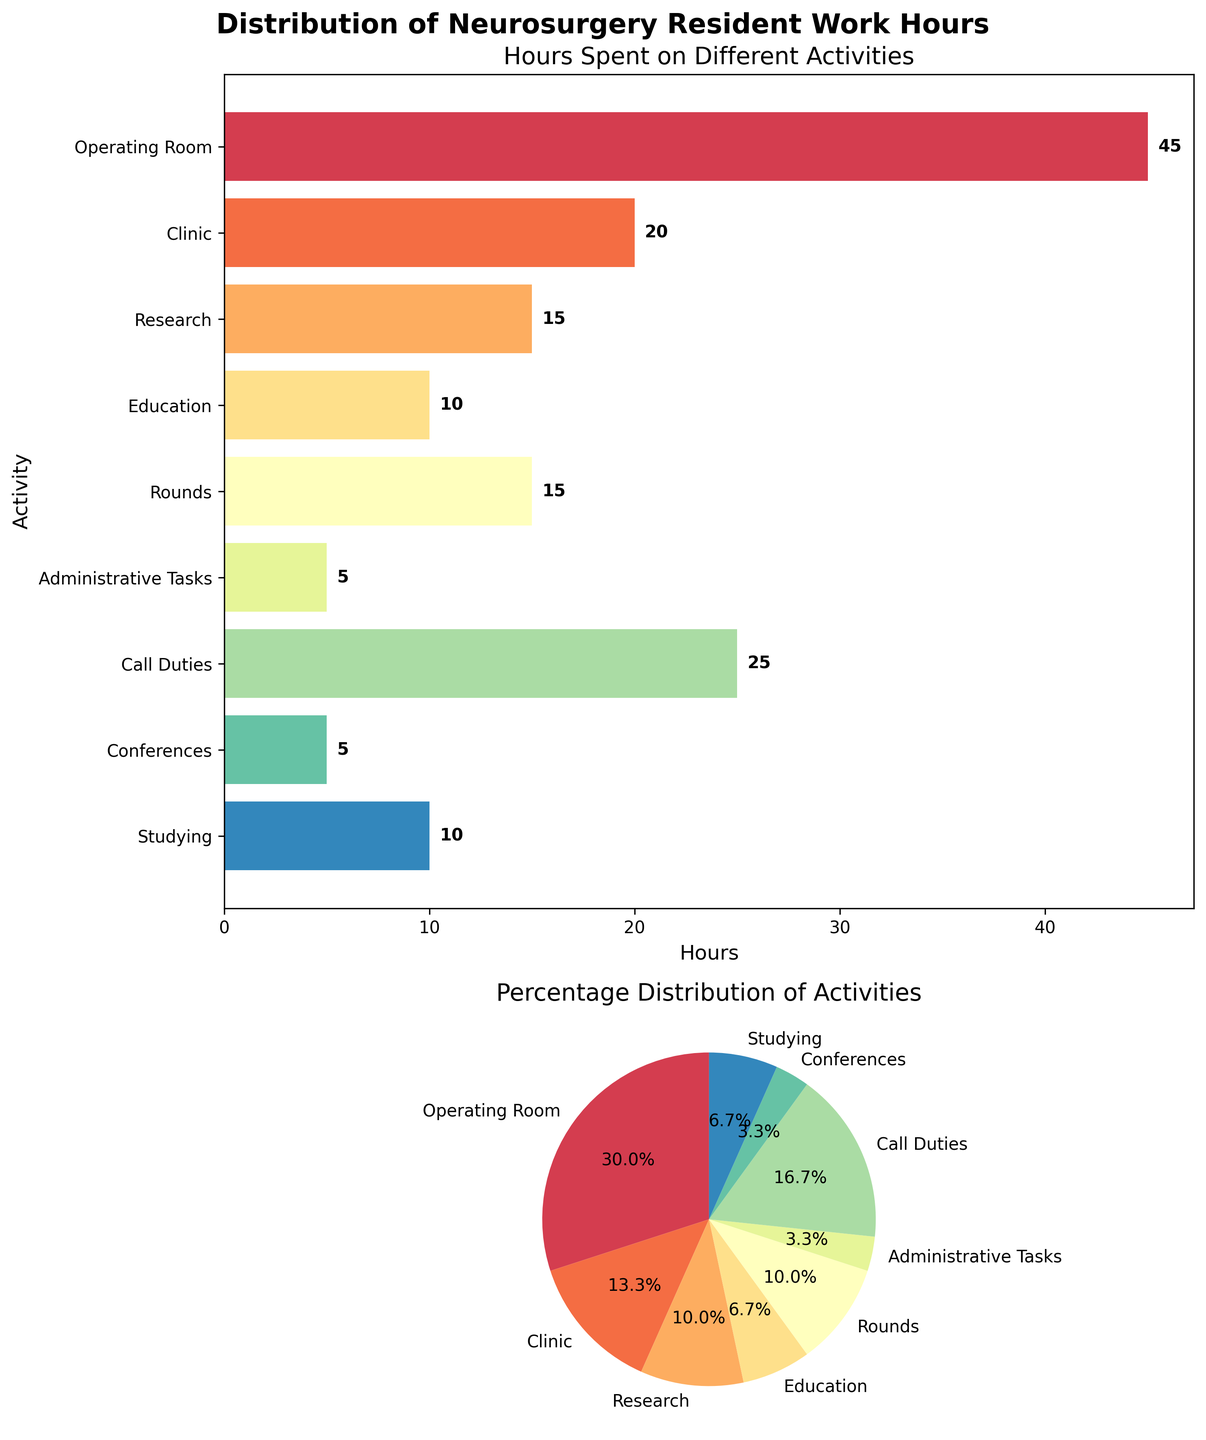How many total hours do neurosurgery residents spend in the operating room? Referring to the horizontal bar plot and the pie chart, the 'Operating Room' bar shows 45 hours.
Answer: 45 What percentage of time is spent on call duties? In the pie chart, the segment for 'Call Duties' has a label of 25%.
Answer: 25% What is the title of the vertical subplots figure? The title is displayed at the top of the figure and reads 'Distribution of Neurosurgery Resident Work Hours'.
Answer: Distribution of Neurosurgery Resident Work Hours Which activity do residents spend the least amount of time on? The shortest bar in the horizontal bar plot and the smallest segment in the pie chart both represent 'Administrative Tasks' with 5 hours.
Answer: Administrative Tasks What is the total time spent by residents on research and education combined? Adding the hours for research (15) and education (10), we get 15 + 10 = 25 hours.
Answer: 25 How does the time spent in the clinic compare to the time spent on studying? In the horizontal bar plot, the 'Clinic' bar shows 20 hours, whereas the 'Studying' bar shows 10 hours, indicating residents spend twice as much time in the clinic.
Answer: Clinic > Studying Which activity takes up more hours: Rounds or Research? Comparing the bars for 'Rounds' (15 hours) and 'Research' (15 hours) in the horizontal bar plot, both activities take the same amount of time.
Answer: Rounds = Research How many distinct activities are listed in the figure? Counting the different bars in the horizontal bar plot and slices in the pie chart, there are 9 activities shown.
Answer: 9 What portion of time do residents spend at conferences compared to administrative tasks? Both 'Conferences' and 'Administrative Tasks' show 5 hours each, indicating equal time allocation.
Answer: Conferences = Administrative Tasks 